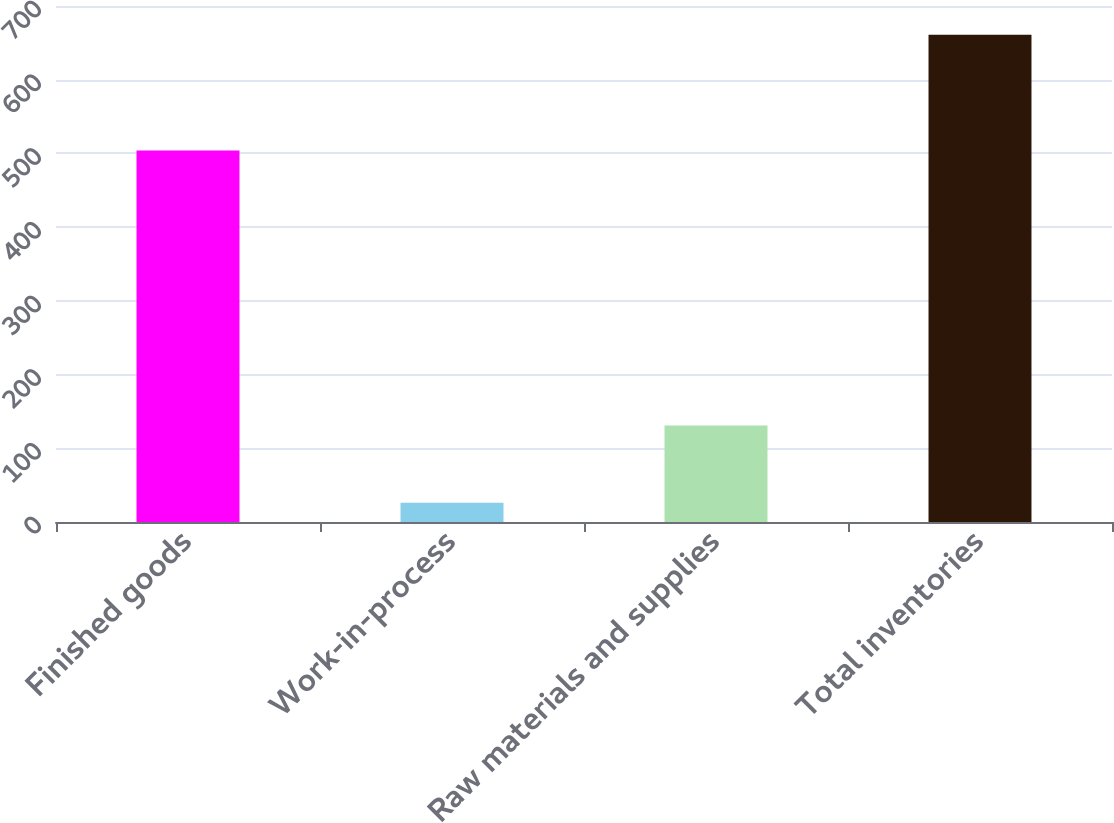<chart> <loc_0><loc_0><loc_500><loc_500><bar_chart><fcel>Finished goods<fcel>Work-in-process<fcel>Raw materials and supplies<fcel>Total inventories<nl><fcel>504<fcel>26<fcel>131<fcel>661<nl></chart> 